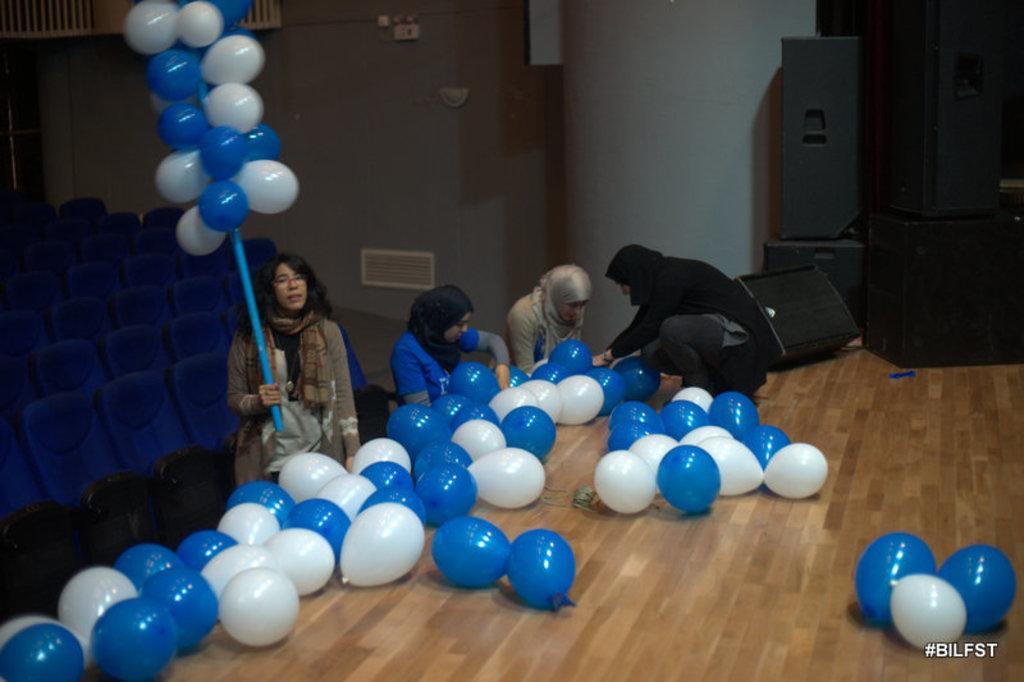Please provide a concise description of this image. In this image, we can see a brown color floor, there are some white and blue color balloons, there are some people sitting and they are holding balloons, at the left side there are some blue color chairs, at the right side there are some black color speakers. 